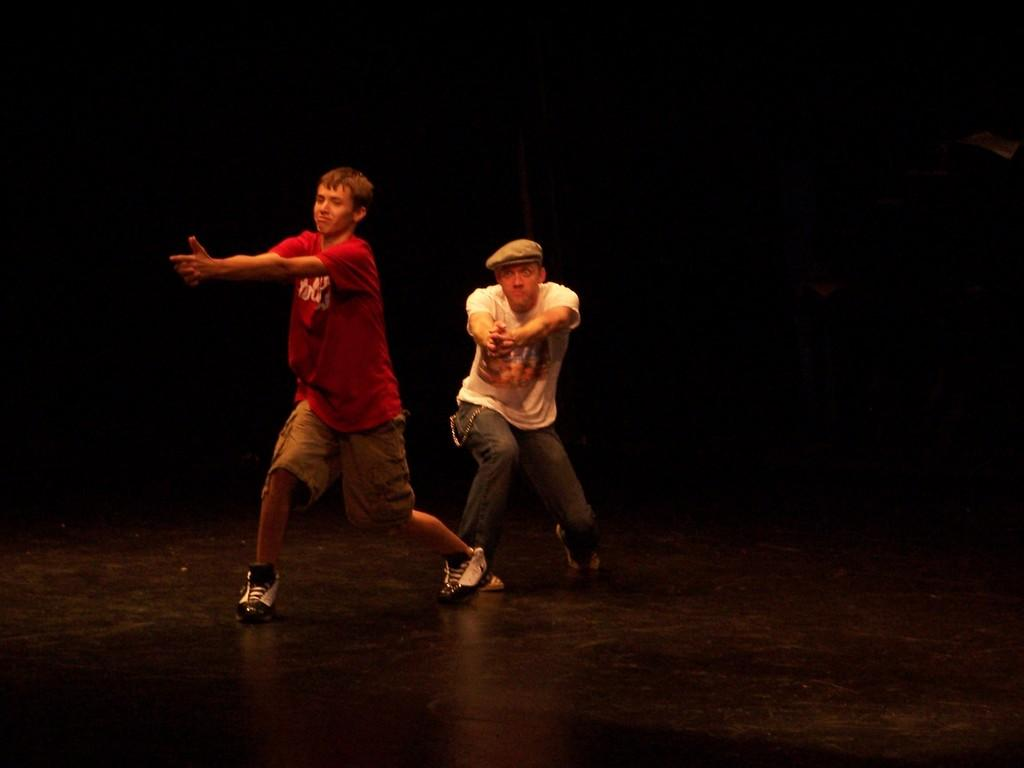How many people are in the image? There are two persons in the image. Can you describe the individuals in the image? One of the persons is a boy, and the other person is a man. What are the boy and the man doing in the image? Both the boy and the man are dancing. What is the boy wearing in the image? The boy is wearing a red T-shirt. How is the man dressed in the image? The man is wearing a white T-shirt and a cap. What can be observed about the background of the image? The background of the image appears to be dark. What type of humor can be seen in the crayon drawings on the wall in the image? There are no crayon drawings or any reference to humor in the image. 